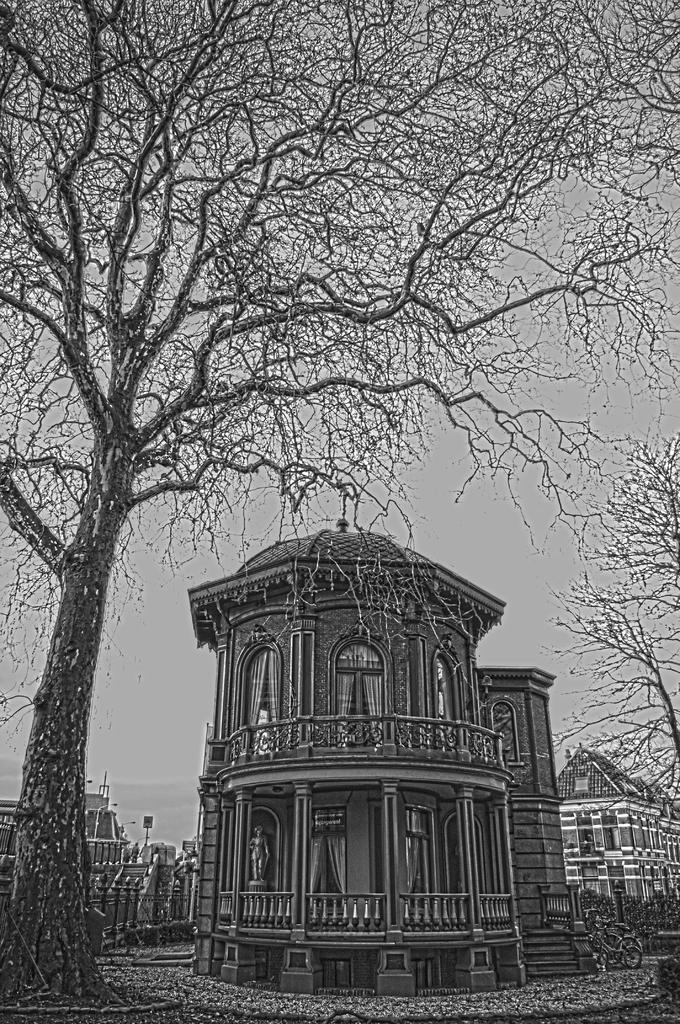What type of structures can be seen in the image? There are buildings in the image. What natural elements are present in the image? There are trees in the image. What mode of transportation is visible in the image? There is a bicycle in the image. What architectural feature can be seen in the image? There is railing in the image. What type of terrain is visible in the image? There is land visible in the image. What can be seen in the background of the image? The sky is visible in the background of the image. How many bees are buzzing around the toothpaste in the image? There are no bees or toothpaste present in the image. What type of war is being depicted in the image? There is no depiction of war in the image; it features buildings, trees, a bicycle, railing, land, and the sky. 